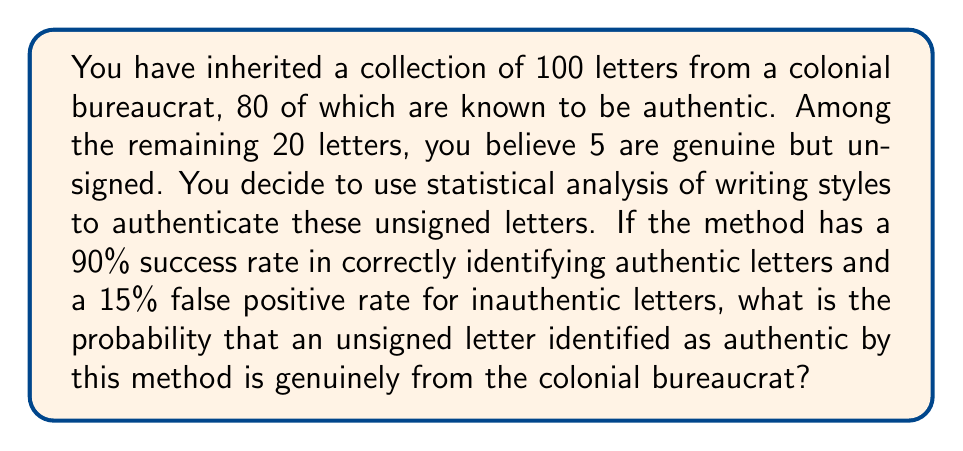Can you solve this math problem? Let's approach this problem using Bayes' Theorem:

1) Define events:
   A: The letter is authentic
   P: The letter is identified as authentic by the statistical analysis

2) Given probabilities:
   P(A) = 5/20 = 0.25 (prior probability of authenticity)
   P(P|A) = 0.90 (true positive rate)
   P(P|not A) = 0.15 (false positive rate)

3) We need to find P(A|P) using Bayes' Theorem:

   $$P(A|P) = \frac{P(P|A) \cdot P(A)}{P(P)}$$

4) Calculate P(P) using the law of total probability:
   $$P(P) = P(P|A) \cdot P(A) + P(P|not A) \cdot P(not A)$$
   $$P(P) = 0.90 \cdot 0.25 + 0.15 \cdot 0.75 = 0.225 + 0.1125 = 0.3375$$

5) Now apply Bayes' Theorem:
   $$P(A|P) = \frac{0.90 \cdot 0.25}{0.3375} = \frac{0.225}{0.3375} = \frac{2}{3} \approx 0.6667$$

Therefore, the probability that an unsigned letter identified as authentic is genuinely from the colonial bureaucrat is approximately 0.6667 or 66.67%.
Answer: $\frac{2}{3}$ or approximately 0.6667 (66.67%) 